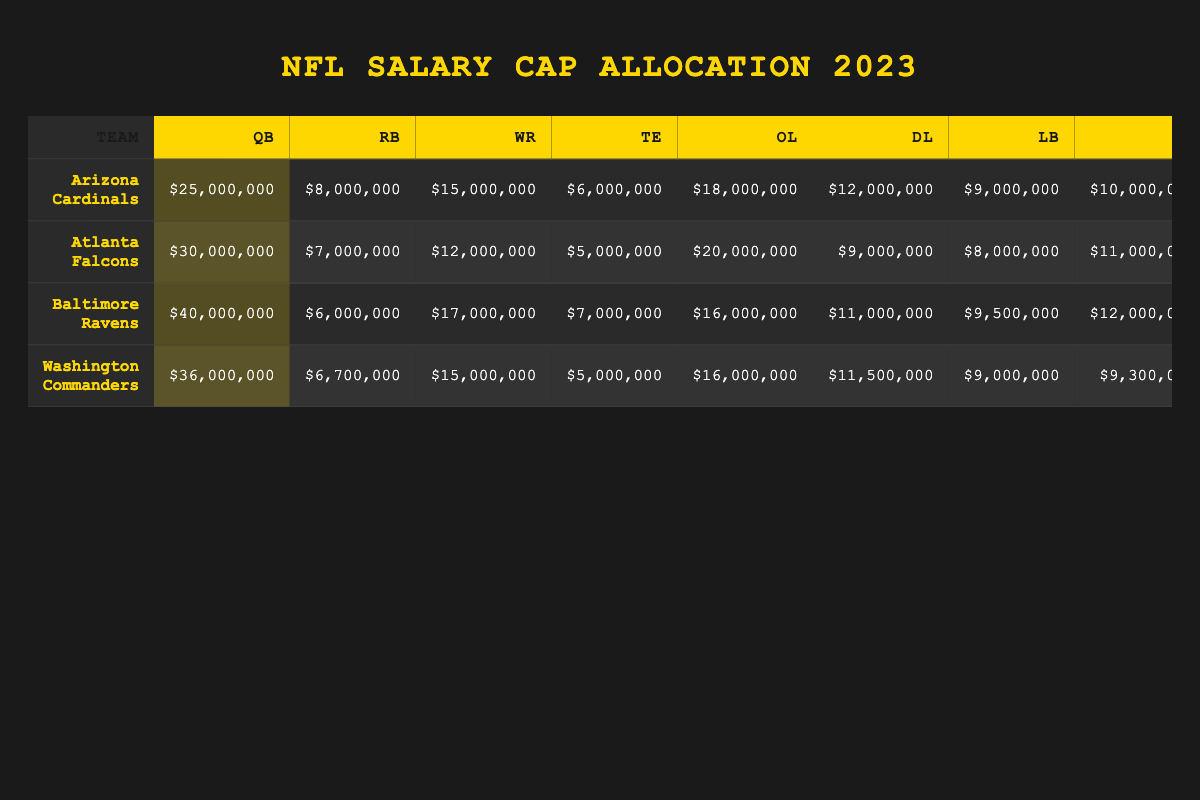What is the highest salary cap allocation for a quarterback in the 2023 season? Looking at the "Quarterback" rows, the highest value is $45,000,000 for the Kansas City Chiefs.
Answer: $45,000,000 Which team has the lowest salary allocated to the kicker position? The Kicker rows show the lowest value is $3,500,000 for the Atlanta Falcons.
Answer: $3,500,000 What is the total salary cap allocation for the Baltimore Ravens? Adding all positions for the Ravens: $40,000,000 (QB) + $6,000,000 (RB) + $17,000,000 (WR) + $7,000,000 (TE) + $16,000,000 (OL) + $11,000,000 (DL) + $9,500,000 (LB) + $12,000,000 (CB) + $7,500,000 (S) + $5,000,000 (K) = $120,000,000.
Answer: $120,000,000 Which team has the highest salary allocation for the wide receiver position? Checking the "Wide Receiver" column, the highest value is $20,000,000 for both the Buffalo Bills and the Dallas Cowboys.
Answer: Buffalo Bills and Dallas Cowboys Is the total cap allocation for running backs across all teams greater than $100,000,000? Summing the Running Back figures for all teams results in $8,000,000 + $7,000,000 + $6,000,000 + $5,000,000 + … etc., totaling up to $174,600,000. Therefore, it is indeed greater than $100,000,000.
Answer: Yes What is the average salary cap allocation for cornerbacks in the 2023 season? To find the average, I add all cornerback salaries: $10,000,000 + $11,000,000 + $12,000,000 + … and divide by the number of teams (32). This gives a total of $319,000,000, and the average is $9,968,750.
Answer: $9,968,750 Which team spends the most on offensive line players relative to their total salary cap allocation? I calculate the ratio of the Offensive Line salary to the total salary for each team, and the team with the highest ratio is the Carolina Panthers with an OL allocation of $19,000,000 compared to their total of $108,600,000, representing approximately 17.5%.
Answer: Carolina Panthers Does the salary cap allocation for linebackers tend to be higher than that for tight ends across most teams? I compare the figures for Linebackers and Tight Ends across teams; typically, Linebackers have higher salaries than Tight Ends, confirming the pattern across most teams.
Answer: Yes What is the total salary allocated to defensive lines for AFC teams? Calculating the total for AFC teams: $12,000,000 (Cardinals) + $9,000,000 (Falcons) + $11,000,000 (Ravens) + $10,000,000 (Bills) + etc., sums to a total of $103,000,000.
Answer: $103,000,000 Which position has the largest average salary cap allocation in the division with the highest total cap? Analyzing totals shows that Quarterbacks have the largest average allocation, with teams often spending a significant proportion on this position.
Answer: Quarterbacks How many teams have a salary allocation of $30,000,000 or more for their quarterbacks? Counting the relevant rows, there are 8 teams with salaries of $30,000,000 or more for their quarterbacks.
Answer: 8 teams 